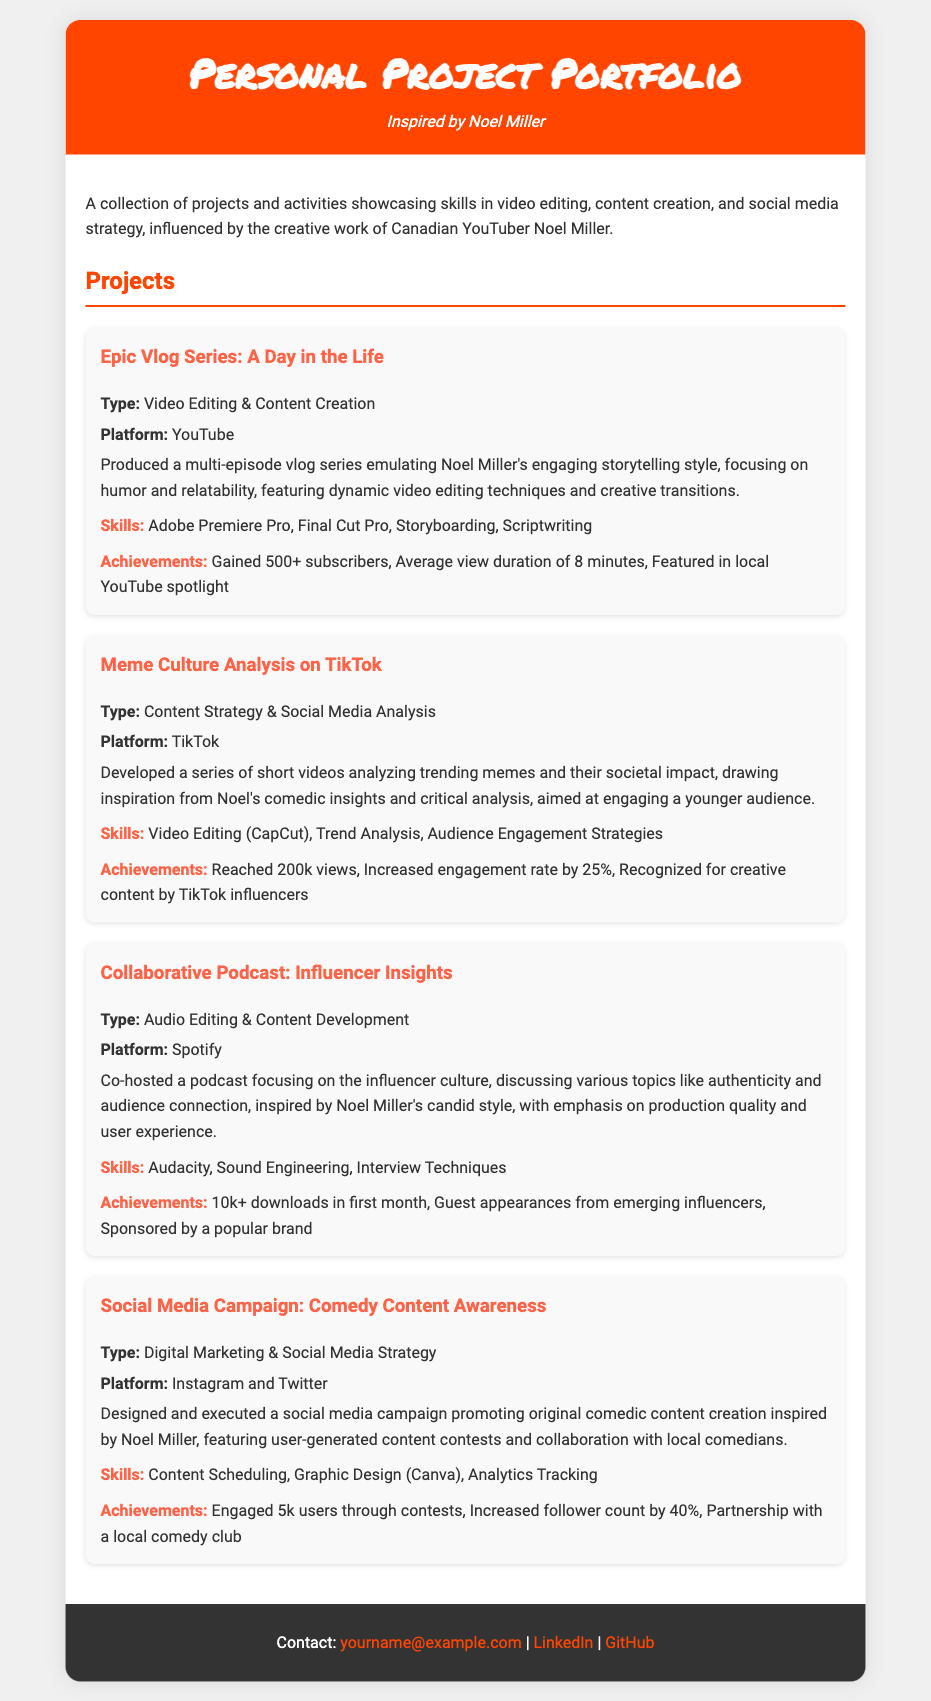what is the title of the document? The title of the document is prominently displayed at the top.
Answer: Personal Project Portfolio who is the inspiration behind the portfolio? The document mentions the influence of a specific individual on the projects presented.
Answer: Noel Miller how many subscribers were gained from the Epic Vlog Series? The number of subscribers achieved from the vlog series is mentioned in the achievements section.
Answer: 500+ what platforms were used for the projects? The platforms for each project are listed in the project descriptions.
Answer: YouTube, TikTok, Spotify, Instagram and Twitter what type of content did the Meme Culture Analysis on TikTok focus on? The specific focus of the content is outlined in the project description.
Answer: Trending memes which software was used for audio editing in the podcast project? The software used for this specific project is mentioned in the skills section.
Answer: Audacity what was the engagement rate increase from the TikTok project? The document provides a specific percentage related to engagement improvement.
Answer: 25% how many downloads did the Collaborative Podcast achieve in the first month? The number of downloads achieved is noted in the achievements section.
Answer: 10k+ what skill is highlighted in the Social Media Campaign project? The skills relevant to the project are listed in the corresponding section.
Answer: Content Scheduling 